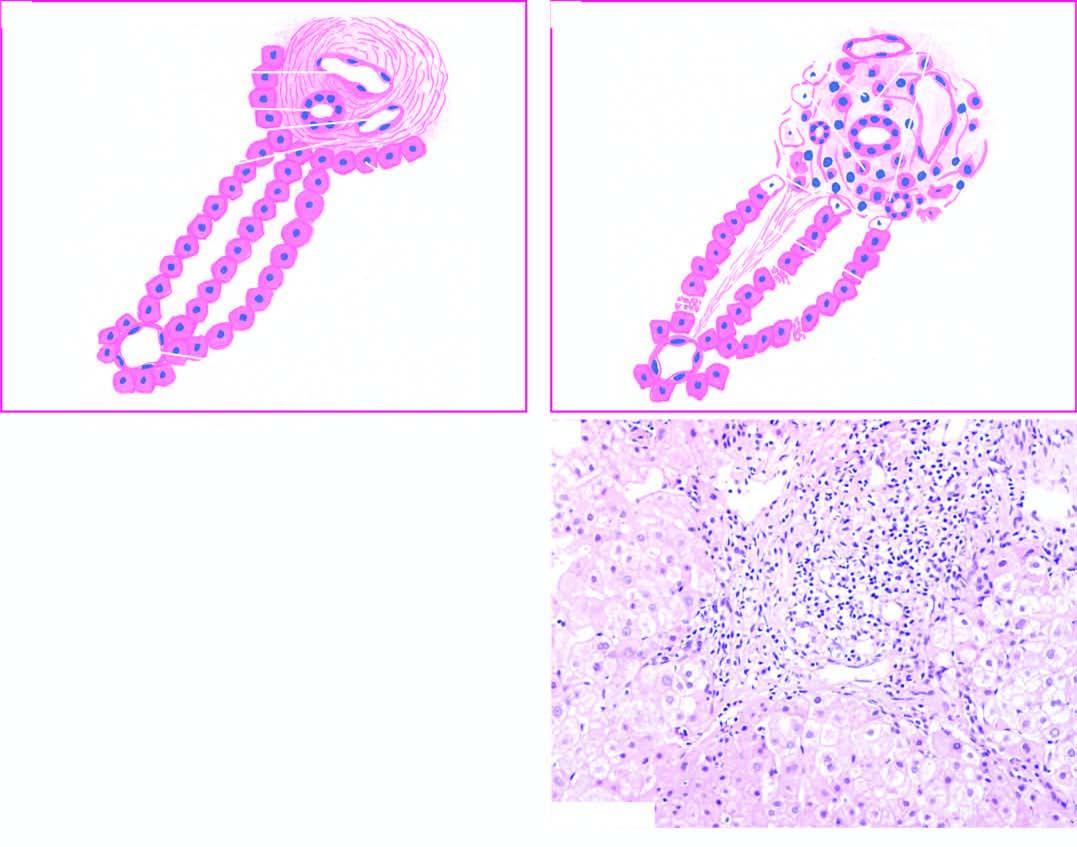what is contrasted with normal morphology a?
Answer the question using a single word or phrase. Diagrammatic representation of pathologic changes in chronic hepatitis 